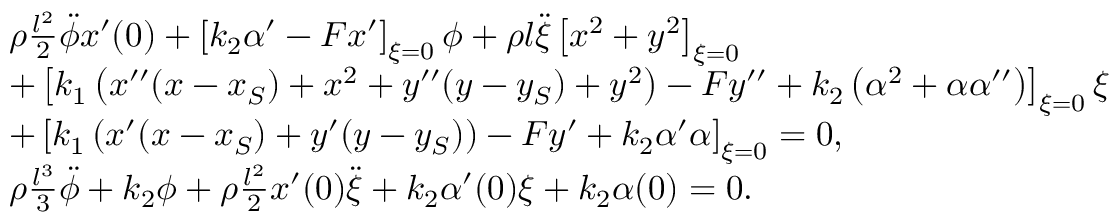Convert formula to latex. <formula><loc_0><loc_0><loc_500><loc_500>\begin{array} { r l } & { \rho \frac { l ^ { 2 } } { 2 } \ddot { \phi } x ^ { \prime } ( 0 ) + \left [ k _ { 2 } \alpha ^ { \prime } - F x ^ { \prime } \right ] _ { \xi = 0 } \phi + \rho l \ddot { \xi } \left [ x ^ { 2 } + y ^ { 2 } \right ] _ { \xi = 0 } } \\ & { + \left [ k _ { 1 } \left ( x ^ { \prime \prime } ( x - x _ { S } ) + x ^ { 2 } + y ^ { \prime \prime } ( y - y _ { S } ) + y ^ { 2 } \right ) - F y ^ { \prime \prime } + k _ { 2 } \left ( \alpha ^ { 2 } + \alpha \alpha ^ { \prime \prime } \right ) \right ] _ { \xi = 0 } \xi } \\ & { + \left [ k _ { 1 } \left ( x ^ { \prime } ( x - x _ { S } ) + y ^ { \prime } ( y - y _ { S } ) \right ) - F y ^ { \prime } + k _ { 2 } \alpha ^ { \prime } \alpha \right ] _ { \xi = 0 } = 0 , } \\ & { \rho \frac { l ^ { 3 } } { 3 } \ddot { \phi } + k _ { 2 } \phi + \rho \frac { l ^ { 2 } } { 2 } x ^ { \prime } ( 0 ) \ddot { \xi } + k _ { 2 } \alpha ^ { \prime } ( 0 ) \xi + k _ { 2 } \alpha ( 0 ) = 0 . } \end{array}</formula> 